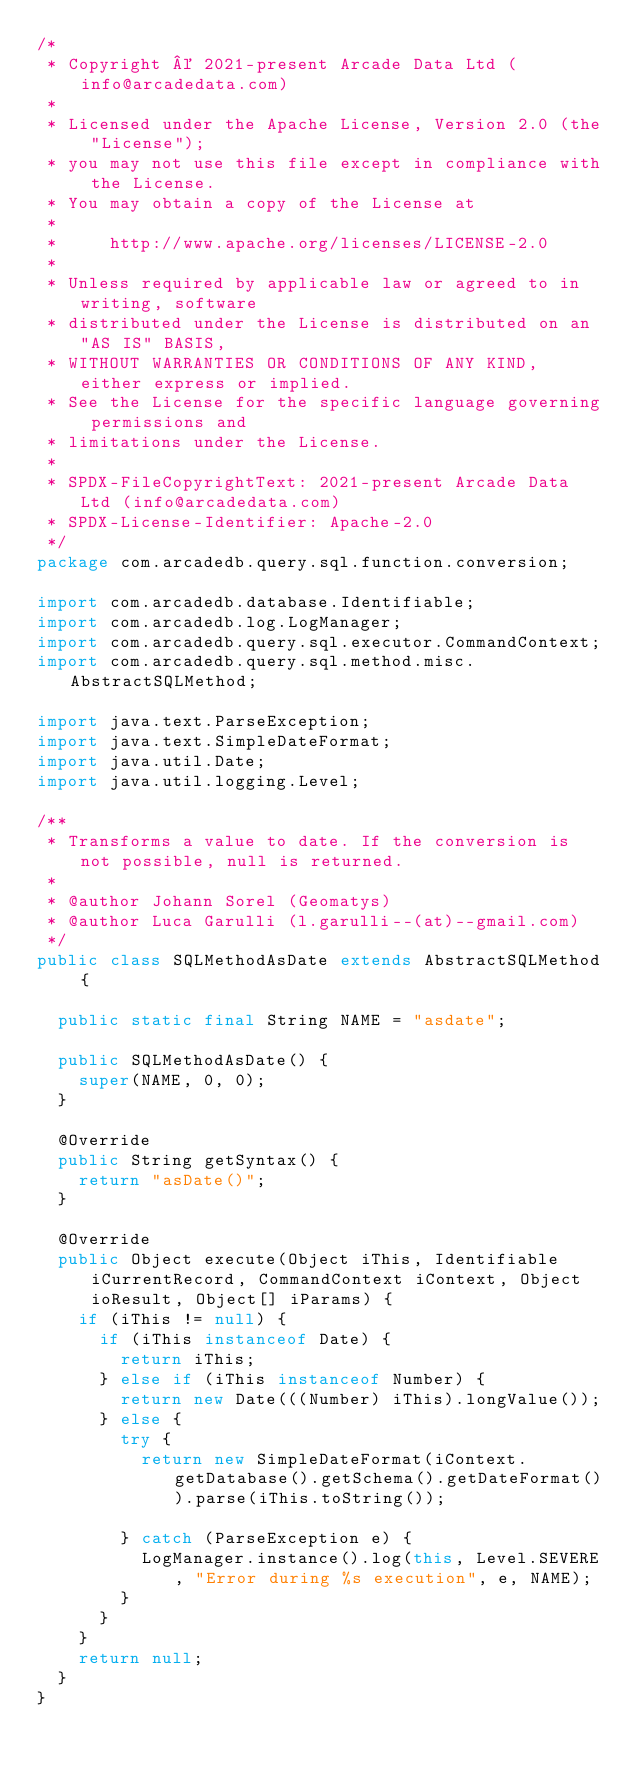<code> <loc_0><loc_0><loc_500><loc_500><_Java_>/*
 * Copyright © 2021-present Arcade Data Ltd (info@arcadedata.com)
 *
 * Licensed under the Apache License, Version 2.0 (the "License");
 * you may not use this file except in compliance with the License.
 * You may obtain a copy of the License at
 *
 *     http://www.apache.org/licenses/LICENSE-2.0
 *
 * Unless required by applicable law or agreed to in writing, software
 * distributed under the License is distributed on an "AS IS" BASIS,
 * WITHOUT WARRANTIES OR CONDITIONS OF ANY KIND, either express or implied.
 * See the License for the specific language governing permissions and
 * limitations under the License.
 *
 * SPDX-FileCopyrightText: 2021-present Arcade Data Ltd (info@arcadedata.com)
 * SPDX-License-Identifier: Apache-2.0
 */
package com.arcadedb.query.sql.function.conversion;

import com.arcadedb.database.Identifiable;
import com.arcadedb.log.LogManager;
import com.arcadedb.query.sql.executor.CommandContext;
import com.arcadedb.query.sql.method.misc.AbstractSQLMethod;

import java.text.ParseException;
import java.text.SimpleDateFormat;
import java.util.Date;
import java.util.logging.Level;

/**
 * Transforms a value to date. If the conversion is not possible, null is returned.
 *
 * @author Johann Sorel (Geomatys)
 * @author Luca Garulli (l.garulli--(at)--gmail.com)
 */
public class SQLMethodAsDate extends AbstractSQLMethod {

  public static final String NAME = "asdate";

  public SQLMethodAsDate() {
    super(NAME, 0, 0);
  }

  @Override
  public String getSyntax() {
    return "asDate()";
  }

  @Override
  public Object execute(Object iThis, Identifiable iCurrentRecord, CommandContext iContext, Object ioResult, Object[] iParams) {
    if (iThis != null) {
      if (iThis instanceof Date) {
        return iThis;
      } else if (iThis instanceof Number) {
        return new Date(((Number) iThis).longValue());
      } else {
        try {
          return new SimpleDateFormat(iContext.getDatabase().getSchema().getDateFormat()).parse(iThis.toString());

        } catch (ParseException e) {
          LogManager.instance().log(this, Level.SEVERE, "Error during %s execution", e, NAME);
        }
      }
    }
    return null;
  }
}
</code> 